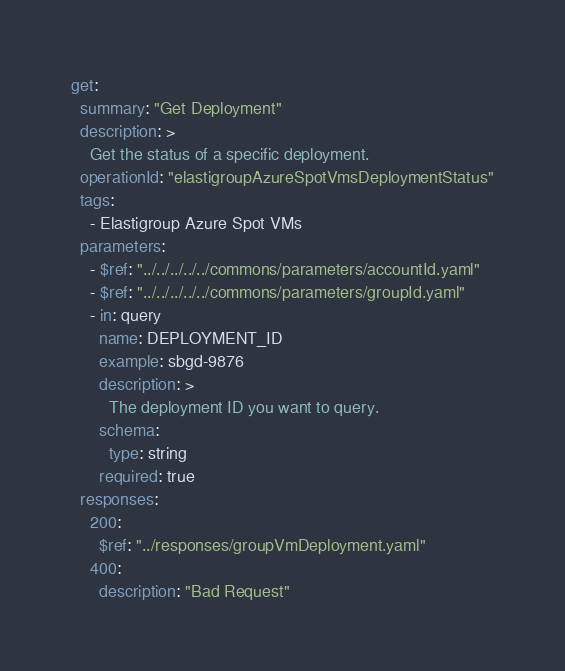<code> <loc_0><loc_0><loc_500><loc_500><_YAML_>get:
  summary: "Get Deployment"
  description: >
    Get the status of a specific deployment.
  operationId: "elastigroupAzureSpotVmsDeploymentStatus"
  tags:
    - Elastigroup Azure Spot VMs
  parameters:
    - $ref: "../../../../../commons/parameters/accountId.yaml"
    - $ref: "../../../../../commons/parameters/groupId.yaml"
    - in: query
      name: DEPLOYMENT_ID
      example: sbgd-9876
      description: >
        The deployment ID you want to query.
      schema:
        type: string
      required: true
  responses:
    200:
      $ref: "../responses/groupVmDeployment.yaml"
    400:
      description: "Bad Request"

</code> 